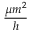<formula> <loc_0><loc_0><loc_500><loc_500>\frac { \mu m ^ { 2 } } { h }</formula> 